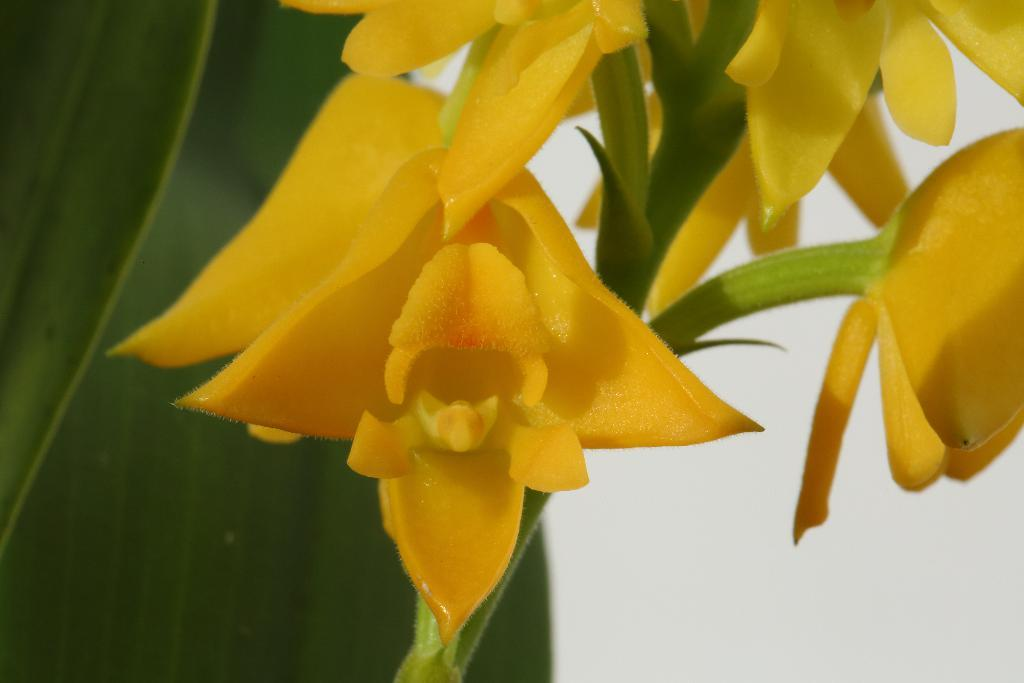What type of flowers can be seen in the image? There are yellow flowers in the image. What are the main parts of the flowers visible in the image? The flowers have stems, and a part of a leaf is visible in the image. What role did zinc play in the history of these flowers? There is no mention of zinc or any historical context in the image, so it is not possible to answer that question. 